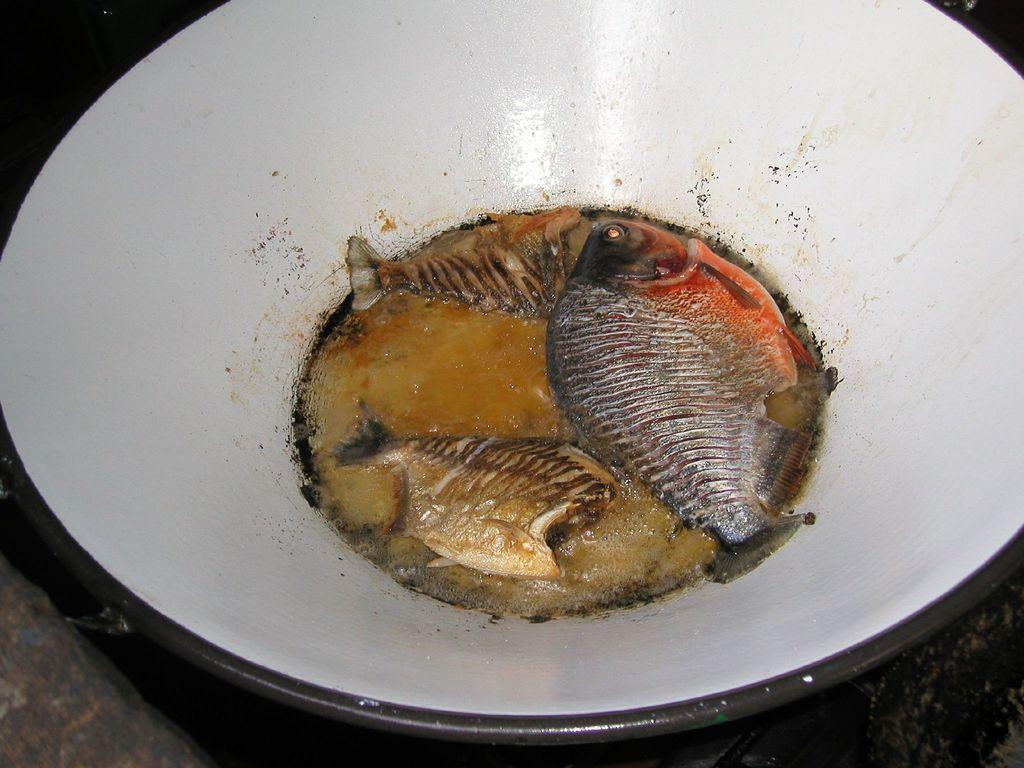How would you summarize this image in a sentence or two? In this image we can see fishes in a bowl placed on the table. 